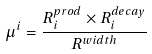Convert formula to latex. <formula><loc_0><loc_0><loc_500><loc_500>\mu ^ { i } = \frac { R _ { i } ^ { p r o d } \times R _ { i } ^ { d e c a y } } { R ^ { w i d t h } }</formula> 